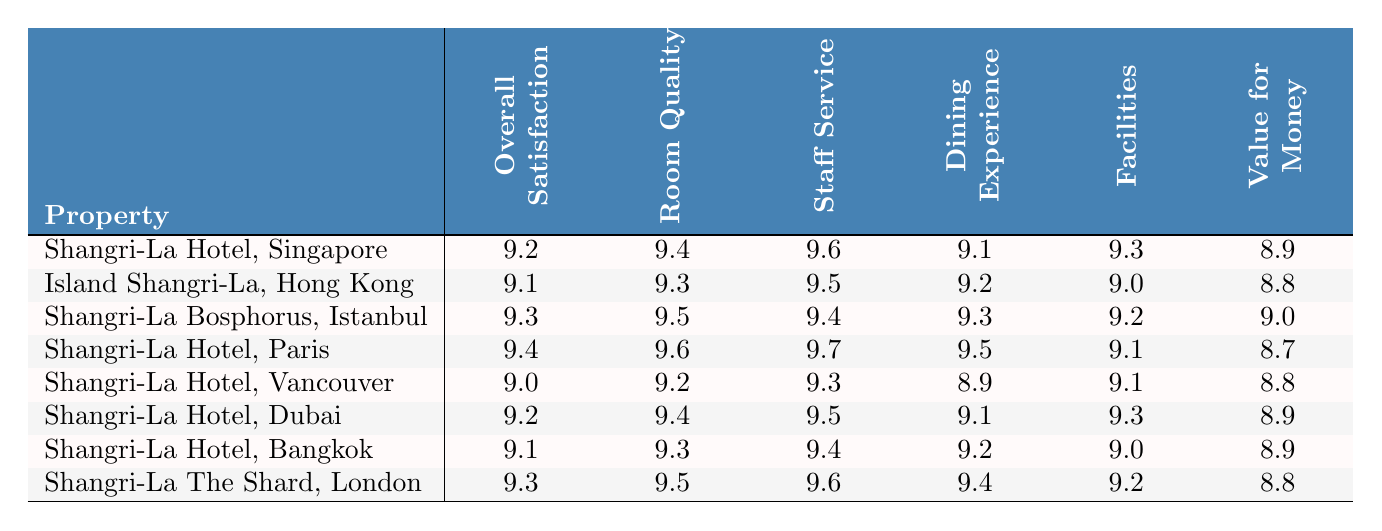What is the overall satisfaction score for Shangri-La Hotel, Paris? The score for overall satisfaction at Shangri-La Hotel, Paris is directly listed in the table, which shows it as 9.4.
Answer: 9.4 Which property has the highest staff service score? By comparing the staff service scores for each property, Shangri-La Hotel, Paris has the highest score at 9.7.
Answer: 9.7 What is the average room quality score across all properties? The room quality scores are 9.4, 9.3, 9.5, 9.6, 9.2, 9.4, 9.3, and 9.5. There are 8 scores, and the sum is 74.3. To find the average, we divide by 8, resulting in 9.2875, which can be rounded to 9.29.
Answer: 9.29 Did Shangri-La Hotel, Dubai have a dining experience score higher than 9.0? The dining experience score for Shangri-La Hotel, Dubai is listed as 9.1, which is indeed higher than 9.0.
Answer: Yes Which property had the lowest overall satisfaction score, and what was it? Analyzing the overall satisfaction scores, the lowest score is 9.0 for Shangri-La Hotel, Vancouver.
Answer: Shangri-La Hotel, Vancouver, 9.0 Is the value for money score consistent across all properties? Reviewing the value for money scores, there are variations: 8.9, 8.8, 9.0, 8.7, and 8.8; thus, the scores are not consistent.
Answer: No What is the difference in overall satisfaction score between Shangri-La Hotel, Singapore and Island Shangri-La, Hong Kong? The overall satisfaction score for Shangri-La Hotel, Singapore is 9.2, and for Island Shangri-La, Hong Kong, it is 9.1. The difference is 9.2 - 9.1 = 0.1.
Answer: 0.1 Which property has the best value for money score? The highest value for money score recorded is 9.0 from Shangri-La Bosphorus, Istanbul, which is higher than the scores of other properties.
Answer: Shangri-La Bosphorus, Istanbul, 9.0 What is the overall satisfaction score trend from Q1 2022 to Q4 2023? The scores are 9.2 (Q1 2022), 9.1 (Q2 2022), 9.3 (Q3 2022), 9.4 (Q4 2022), 9.0 (Q1 2023), 9.2 (Q2 2023), 9.1 (Q3 2023), and 9.3 (Q4 2023). Overall, the trend shows a peak in Q4 2022 but shows some fluctuation, with a slight decrease in early 2023 before reaching a high again in Q4 2023.
Answer: Fluctuating trend with peak in Q4 2022 